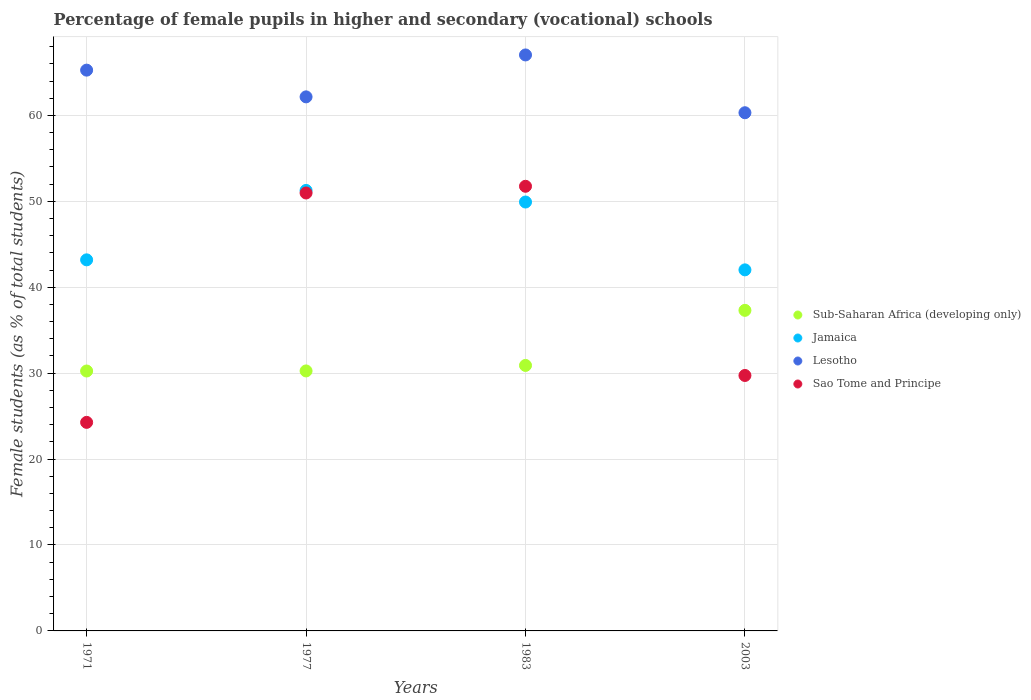How many different coloured dotlines are there?
Offer a very short reply. 4. Is the number of dotlines equal to the number of legend labels?
Your response must be concise. Yes. What is the percentage of female pupils in higher and secondary schools in Sub-Saharan Africa (developing only) in 1971?
Give a very brief answer. 30.25. Across all years, what is the maximum percentage of female pupils in higher and secondary schools in Sub-Saharan Africa (developing only)?
Provide a succinct answer. 37.31. Across all years, what is the minimum percentage of female pupils in higher and secondary schools in Sao Tome and Principe?
Offer a terse response. 24.27. In which year was the percentage of female pupils in higher and secondary schools in Lesotho maximum?
Give a very brief answer. 1983. In which year was the percentage of female pupils in higher and secondary schools in Lesotho minimum?
Keep it short and to the point. 2003. What is the total percentage of female pupils in higher and secondary schools in Lesotho in the graph?
Ensure brevity in your answer.  254.76. What is the difference between the percentage of female pupils in higher and secondary schools in Jamaica in 1971 and that in 2003?
Provide a short and direct response. 1.17. What is the difference between the percentage of female pupils in higher and secondary schools in Sao Tome and Principe in 1971 and the percentage of female pupils in higher and secondary schools in Jamaica in 2003?
Offer a terse response. -17.75. What is the average percentage of female pupils in higher and secondary schools in Lesotho per year?
Provide a succinct answer. 63.69. In the year 1971, what is the difference between the percentage of female pupils in higher and secondary schools in Jamaica and percentage of female pupils in higher and secondary schools in Sub-Saharan Africa (developing only)?
Give a very brief answer. 12.94. What is the ratio of the percentage of female pupils in higher and secondary schools in Jamaica in 1977 to that in 2003?
Offer a terse response. 1.22. Is the difference between the percentage of female pupils in higher and secondary schools in Jamaica in 1971 and 2003 greater than the difference between the percentage of female pupils in higher and secondary schools in Sub-Saharan Africa (developing only) in 1971 and 2003?
Offer a very short reply. Yes. What is the difference between the highest and the second highest percentage of female pupils in higher and secondary schools in Jamaica?
Offer a very short reply. 1.35. What is the difference between the highest and the lowest percentage of female pupils in higher and secondary schools in Sao Tome and Principe?
Make the answer very short. 27.48. Is it the case that in every year, the sum of the percentage of female pupils in higher and secondary schools in Sub-Saharan Africa (developing only) and percentage of female pupils in higher and secondary schools in Jamaica  is greater than the sum of percentage of female pupils in higher and secondary schools in Sao Tome and Principe and percentage of female pupils in higher and secondary schools in Lesotho?
Ensure brevity in your answer.  Yes. Is it the case that in every year, the sum of the percentage of female pupils in higher and secondary schools in Sub-Saharan Africa (developing only) and percentage of female pupils in higher and secondary schools in Sao Tome and Principe  is greater than the percentage of female pupils in higher and secondary schools in Lesotho?
Your answer should be compact. No. Is the percentage of female pupils in higher and secondary schools in Sub-Saharan Africa (developing only) strictly less than the percentage of female pupils in higher and secondary schools in Lesotho over the years?
Your answer should be compact. Yes. How many dotlines are there?
Your answer should be compact. 4. Does the graph contain any zero values?
Offer a very short reply. No. Does the graph contain grids?
Provide a succinct answer. Yes. Where does the legend appear in the graph?
Make the answer very short. Center right. How many legend labels are there?
Offer a terse response. 4. What is the title of the graph?
Provide a succinct answer. Percentage of female pupils in higher and secondary (vocational) schools. Does "Cameroon" appear as one of the legend labels in the graph?
Your answer should be compact. No. What is the label or title of the X-axis?
Give a very brief answer. Years. What is the label or title of the Y-axis?
Your answer should be very brief. Female students (as % of total students). What is the Female students (as % of total students) of Sub-Saharan Africa (developing only) in 1971?
Offer a terse response. 30.25. What is the Female students (as % of total students) in Jamaica in 1971?
Ensure brevity in your answer.  43.19. What is the Female students (as % of total students) in Lesotho in 1971?
Keep it short and to the point. 65.27. What is the Female students (as % of total students) in Sao Tome and Principe in 1971?
Your answer should be very brief. 24.27. What is the Female students (as % of total students) in Sub-Saharan Africa (developing only) in 1977?
Ensure brevity in your answer.  30.26. What is the Female students (as % of total students) in Jamaica in 1977?
Provide a short and direct response. 51.27. What is the Female students (as % of total students) in Lesotho in 1977?
Make the answer very short. 62.16. What is the Female students (as % of total students) in Sao Tome and Principe in 1977?
Ensure brevity in your answer.  50.97. What is the Female students (as % of total students) of Sub-Saharan Africa (developing only) in 1983?
Provide a succinct answer. 30.9. What is the Female students (as % of total students) of Jamaica in 1983?
Your answer should be very brief. 49.92. What is the Female students (as % of total students) in Lesotho in 1983?
Make the answer very short. 67.03. What is the Female students (as % of total students) of Sao Tome and Principe in 1983?
Offer a very short reply. 51.75. What is the Female students (as % of total students) of Sub-Saharan Africa (developing only) in 2003?
Keep it short and to the point. 37.31. What is the Female students (as % of total students) of Jamaica in 2003?
Provide a succinct answer. 42.02. What is the Female students (as % of total students) of Lesotho in 2003?
Offer a terse response. 60.31. What is the Female students (as % of total students) of Sao Tome and Principe in 2003?
Keep it short and to the point. 29.73. Across all years, what is the maximum Female students (as % of total students) of Sub-Saharan Africa (developing only)?
Make the answer very short. 37.31. Across all years, what is the maximum Female students (as % of total students) of Jamaica?
Ensure brevity in your answer.  51.27. Across all years, what is the maximum Female students (as % of total students) of Lesotho?
Offer a very short reply. 67.03. Across all years, what is the maximum Female students (as % of total students) of Sao Tome and Principe?
Offer a very short reply. 51.75. Across all years, what is the minimum Female students (as % of total students) of Sub-Saharan Africa (developing only)?
Provide a short and direct response. 30.25. Across all years, what is the minimum Female students (as % of total students) of Jamaica?
Provide a succinct answer. 42.02. Across all years, what is the minimum Female students (as % of total students) in Lesotho?
Your answer should be compact. 60.31. Across all years, what is the minimum Female students (as % of total students) of Sao Tome and Principe?
Provide a short and direct response. 24.27. What is the total Female students (as % of total students) in Sub-Saharan Africa (developing only) in the graph?
Your answer should be very brief. 128.72. What is the total Female students (as % of total students) in Jamaica in the graph?
Provide a short and direct response. 186.39. What is the total Female students (as % of total students) of Lesotho in the graph?
Give a very brief answer. 254.76. What is the total Female students (as % of total students) in Sao Tome and Principe in the graph?
Ensure brevity in your answer.  156.72. What is the difference between the Female students (as % of total students) in Sub-Saharan Africa (developing only) in 1971 and that in 1977?
Give a very brief answer. -0.01. What is the difference between the Female students (as % of total students) of Jamaica in 1971 and that in 1977?
Give a very brief answer. -8.08. What is the difference between the Female students (as % of total students) in Lesotho in 1971 and that in 1977?
Offer a terse response. 3.11. What is the difference between the Female students (as % of total students) of Sao Tome and Principe in 1971 and that in 1977?
Give a very brief answer. -26.7. What is the difference between the Female students (as % of total students) of Sub-Saharan Africa (developing only) in 1971 and that in 1983?
Offer a terse response. -0.65. What is the difference between the Female students (as % of total students) in Jamaica in 1971 and that in 1983?
Ensure brevity in your answer.  -6.73. What is the difference between the Female students (as % of total students) of Lesotho in 1971 and that in 1983?
Provide a succinct answer. -1.77. What is the difference between the Female students (as % of total students) of Sao Tome and Principe in 1971 and that in 1983?
Give a very brief answer. -27.48. What is the difference between the Female students (as % of total students) of Sub-Saharan Africa (developing only) in 1971 and that in 2003?
Keep it short and to the point. -7.06. What is the difference between the Female students (as % of total students) of Jamaica in 1971 and that in 2003?
Keep it short and to the point. 1.17. What is the difference between the Female students (as % of total students) of Lesotho in 1971 and that in 2003?
Offer a terse response. 4.96. What is the difference between the Female students (as % of total students) in Sao Tome and Principe in 1971 and that in 2003?
Provide a succinct answer. -5.46. What is the difference between the Female students (as % of total students) of Sub-Saharan Africa (developing only) in 1977 and that in 1983?
Offer a terse response. -0.64. What is the difference between the Female students (as % of total students) in Jamaica in 1977 and that in 1983?
Make the answer very short. 1.35. What is the difference between the Female students (as % of total students) of Lesotho in 1977 and that in 1983?
Your answer should be very brief. -4.88. What is the difference between the Female students (as % of total students) in Sao Tome and Principe in 1977 and that in 1983?
Your answer should be compact. -0.78. What is the difference between the Female students (as % of total students) in Sub-Saharan Africa (developing only) in 1977 and that in 2003?
Offer a very short reply. -7.05. What is the difference between the Female students (as % of total students) of Jamaica in 1977 and that in 2003?
Offer a very short reply. 9.24. What is the difference between the Female students (as % of total students) in Lesotho in 1977 and that in 2003?
Provide a short and direct response. 1.85. What is the difference between the Female students (as % of total students) of Sao Tome and Principe in 1977 and that in 2003?
Offer a very short reply. 21.24. What is the difference between the Female students (as % of total students) in Sub-Saharan Africa (developing only) in 1983 and that in 2003?
Your response must be concise. -6.41. What is the difference between the Female students (as % of total students) of Jamaica in 1983 and that in 2003?
Provide a short and direct response. 7.9. What is the difference between the Female students (as % of total students) of Lesotho in 1983 and that in 2003?
Your response must be concise. 6.73. What is the difference between the Female students (as % of total students) of Sao Tome and Principe in 1983 and that in 2003?
Offer a very short reply. 22.02. What is the difference between the Female students (as % of total students) in Sub-Saharan Africa (developing only) in 1971 and the Female students (as % of total students) in Jamaica in 1977?
Your response must be concise. -21.02. What is the difference between the Female students (as % of total students) in Sub-Saharan Africa (developing only) in 1971 and the Female students (as % of total students) in Lesotho in 1977?
Offer a very short reply. -31.91. What is the difference between the Female students (as % of total students) of Sub-Saharan Africa (developing only) in 1971 and the Female students (as % of total students) of Sao Tome and Principe in 1977?
Keep it short and to the point. -20.72. What is the difference between the Female students (as % of total students) of Jamaica in 1971 and the Female students (as % of total students) of Lesotho in 1977?
Your answer should be compact. -18.97. What is the difference between the Female students (as % of total students) in Jamaica in 1971 and the Female students (as % of total students) in Sao Tome and Principe in 1977?
Provide a short and direct response. -7.78. What is the difference between the Female students (as % of total students) of Lesotho in 1971 and the Female students (as % of total students) of Sao Tome and Principe in 1977?
Offer a very short reply. 14.3. What is the difference between the Female students (as % of total students) in Sub-Saharan Africa (developing only) in 1971 and the Female students (as % of total students) in Jamaica in 1983?
Offer a very short reply. -19.67. What is the difference between the Female students (as % of total students) in Sub-Saharan Africa (developing only) in 1971 and the Female students (as % of total students) in Lesotho in 1983?
Give a very brief answer. -36.78. What is the difference between the Female students (as % of total students) of Sub-Saharan Africa (developing only) in 1971 and the Female students (as % of total students) of Sao Tome and Principe in 1983?
Your answer should be very brief. -21.5. What is the difference between the Female students (as % of total students) of Jamaica in 1971 and the Female students (as % of total students) of Lesotho in 1983?
Give a very brief answer. -23.85. What is the difference between the Female students (as % of total students) of Jamaica in 1971 and the Female students (as % of total students) of Sao Tome and Principe in 1983?
Provide a succinct answer. -8.56. What is the difference between the Female students (as % of total students) in Lesotho in 1971 and the Female students (as % of total students) in Sao Tome and Principe in 1983?
Provide a short and direct response. 13.52. What is the difference between the Female students (as % of total students) in Sub-Saharan Africa (developing only) in 1971 and the Female students (as % of total students) in Jamaica in 2003?
Ensure brevity in your answer.  -11.77. What is the difference between the Female students (as % of total students) of Sub-Saharan Africa (developing only) in 1971 and the Female students (as % of total students) of Lesotho in 2003?
Offer a terse response. -30.06. What is the difference between the Female students (as % of total students) of Sub-Saharan Africa (developing only) in 1971 and the Female students (as % of total students) of Sao Tome and Principe in 2003?
Provide a succinct answer. 0.52. What is the difference between the Female students (as % of total students) in Jamaica in 1971 and the Female students (as % of total students) in Lesotho in 2003?
Give a very brief answer. -17.12. What is the difference between the Female students (as % of total students) of Jamaica in 1971 and the Female students (as % of total students) of Sao Tome and Principe in 2003?
Your response must be concise. 13.46. What is the difference between the Female students (as % of total students) of Lesotho in 1971 and the Female students (as % of total students) of Sao Tome and Principe in 2003?
Ensure brevity in your answer.  35.54. What is the difference between the Female students (as % of total students) in Sub-Saharan Africa (developing only) in 1977 and the Female students (as % of total students) in Jamaica in 1983?
Provide a succinct answer. -19.66. What is the difference between the Female students (as % of total students) of Sub-Saharan Africa (developing only) in 1977 and the Female students (as % of total students) of Lesotho in 1983?
Provide a short and direct response. -36.77. What is the difference between the Female students (as % of total students) in Sub-Saharan Africa (developing only) in 1977 and the Female students (as % of total students) in Sao Tome and Principe in 1983?
Give a very brief answer. -21.49. What is the difference between the Female students (as % of total students) of Jamaica in 1977 and the Female students (as % of total students) of Lesotho in 1983?
Provide a short and direct response. -15.77. What is the difference between the Female students (as % of total students) in Jamaica in 1977 and the Female students (as % of total students) in Sao Tome and Principe in 1983?
Your answer should be compact. -0.48. What is the difference between the Female students (as % of total students) in Lesotho in 1977 and the Female students (as % of total students) in Sao Tome and Principe in 1983?
Your response must be concise. 10.41. What is the difference between the Female students (as % of total students) in Sub-Saharan Africa (developing only) in 1977 and the Female students (as % of total students) in Jamaica in 2003?
Give a very brief answer. -11.76. What is the difference between the Female students (as % of total students) in Sub-Saharan Africa (developing only) in 1977 and the Female students (as % of total students) in Lesotho in 2003?
Give a very brief answer. -30.05. What is the difference between the Female students (as % of total students) of Sub-Saharan Africa (developing only) in 1977 and the Female students (as % of total students) of Sao Tome and Principe in 2003?
Give a very brief answer. 0.53. What is the difference between the Female students (as % of total students) of Jamaica in 1977 and the Female students (as % of total students) of Lesotho in 2003?
Make the answer very short. -9.04. What is the difference between the Female students (as % of total students) of Jamaica in 1977 and the Female students (as % of total students) of Sao Tome and Principe in 2003?
Give a very brief answer. 21.54. What is the difference between the Female students (as % of total students) in Lesotho in 1977 and the Female students (as % of total students) in Sao Tome and Principe in 2003?
Your answer should be compact. 32.43. What is the difference between the Female students (as % of total students) of Sub-Saharan Africa (developing only) in 1983 and the Female students (as % of total students) of Jamaica in 2003?
Offer a very short reply. -11.12. What is the difference between the Female students (as % of total students) of Sub-Saharan Africa (developing only) in 1983 and the Female students (as % of total students) of Lesotho in 2003?
Your answer should be very brief. -29.41. What is the difference between the Female students (as % of total students) of Sub-Saharan Africa (developing only) in 1983 and the Female students (as % of total students) of Sao Tome and Principe in 2003?
Provide a short and direct response. 1.17. What is the difference between the Female students (as % of total students) in Jamaica in 1983 and the Female students (as % of total students) in Lesotho in 2003?
Ensure brevity in your answer.  -10.39. What is the difference between the Female students (as % of total students) of Jamaica in 1983 and the Female students (as % of total students) of Sao Tome and Principe in 2003?
Keep it short and to the point. 20.19. What is the difference between the Female students (as % of total students) of Lesotho in 1983 and the Female students (as % of total students) of Sao Tome and Principe in 2003?
Offer a terse response. 37.3. What is the average Female students (as % of total students) of Sub-Saharan Africa (developing only) per year?
Your response must be concise. 32.18. What is the average Female students (as % of total students) in Jamaica per year?
Provide a short and direct response. 46.6. What is the average Female students (as % of total students) of Lesotho per year?
Make the answer very short. 63.69. What is the average Female students (as % of total students) in Sao Tome and Principe per year?
Ensure brevity in your answer.  39.18. In the year 1971, what is the difference between the Female students (as % of total students) of Sub-Saharan Africa (developing only) and Female students (as % of total students) of Jamaica?
Provide a short and direct response. -12.94. In the year 1971, what is the difference between the Female students (as % of total students) of Sub-Saharan Africa (developing only) and Female students (as % of total students) of Lesotho?
Offer a terse response. -35.02. In the year 1971, what is the difference between the Female students (as % of total students) of Sub-Saharan Africa (developing only) and Female students (as % of total students) of Sao Tome and Principe?
Provide a succinct answer. 5.98. In the year 1971, what is the difference between the Female students (as % of total students) in Jamaica and Female students (as % of total students) in Lesotho?
Ensure brevity in your answer.  -22.08. In the year 1971, what is the difference between the Female students (as % of total students) in Jamaica and Female students (as % of total students) in Sao Tome and Principe?
Give a very brief answer. 18.92. In the year 1971, what is the difference between the Female students (as % of total students) in Lesotho and Female students (as % of total students) in Sao Tome and Principe?
Offer a terse response. 40.99. In the year 1977, what is the difference between the Female students (as % of total students) of Sub-Saharan Africa (developing only) and Female students (as % of total students) of Jamaica?
Ensure brevity in your answer.  -21.01. In the year 1977, what is the difference between the Female students (as % of total students) in Sub-Saharan Africa (developing only) and Female students (as % of total students) in Lesotho?
Provide a short and direct response. -31.9. In the year 1977, what is the difference between the Female students (as % of total students) in Sub-Saharan Africa (developing only) and Female students (as % of total students) in Sao Tome and Principe?
Offer a very short reply. -20.71. In the year 1977, what is the difference between the Female students (as % of total students) in Jamaica and Female students (as % of total students) in Lesotho?
Give a very brief answer. -10.89. In the year 1977, what is the difference between the Female students (as % of total students) of Jamaica and Female students (as % of total students) of Sao Tome and Principe?
Keep it short and to the point. 0.3. In the year 1977, what is the difference between the Female students (as % of total students) of Lesotho and Female students (as % of total students) of Sao Tome and Principe?
Your response must be concise. 11.19. In the year 1983, what is the difference between the Female students (as % of total students) in Sub-Saharan Africa (developing only) and Female students (as % of total students) in Jamaica?
Offer a very short reply. -19.02. In the year 1983, what is the difference between the Female students (as % of total students) in Sub-Saharan Africa (developing only) and Female students (as % of total students) in Lesotho?
Ensure brevity in your answer.  -36.14. In the year 1983, what is the difference between the Female students (as % of total students) in Sub-Saharan Africa (developing only) and Female students (as % of total students) in Sao Tome and Principe?
Offer a terse response. -20.85. In the year 1983, what is the difference between the Female students (as % of total students) of Jamaica and Female students (as % of total students) of Lesotho?
Your response must be concise. -17.12. In the year 1983, what is the difference between the Female students (as % of total students) in Jamaica and Female students (as % of total students) in Sao Tome and Principe?
Keep it short and to the point. -1.83. In the year 1983, what is the difference between the Female students (as % of total students) of Lesotho and Female students (as % of total students) of Sao Tome and Principe?
Provide a short and direct response. 15.29. In the year 2003, what is the difference between the Female students (as % of total students) in Sub-Saharan Africa (developing only) and Female students (as % of total students) in Jamaica?
Your answer should be compact. -4.71. In the year 2003, what is the difference between the Female students (as % of total students) of Sub-Saharan Africa (developing only) and Female students (as % of total students) of Lesotho?
Ensure brevity in your answer.  -23. In the year 2003, what is the difference between the Female students (as % of total students) of Sub-Saharan Africa (developing only) and Female students (as % of total students) of Sao Tome and Principe?
Offer a terse response. 7.58. In the year 2003, what is the difference between the Female students (as % of total students) in Jamaica and Female students (as % of total students) in Lesotho?
Offer a terse response. -18.29. In the year 2003, what is the difference between the Female students (as % of total students) in Jamaica and Female students (as % of total students) in Sao Tome and Principe?
Offer a very short reply. 12.29. In the year 2003, what is the difference between the Female students (as % of total students) in Lesotho and Female students (as % of total students) in Sao Tome and Principe?
Provide a short and direct response. 30.58. What is the ratio of the Female students (as % of total students) of Sub-Saharan Africa (developing only) in 1971 to that in 1977?
Your answer should be compact. 1. What is the ratio of the Female students (as % of total students) of Jamaica in 1971 to that in 1977?
Offer a very short reply. 0.84. What is the ratio of the Female students (as % of total students) in Sao Tome and Principe in 1971 to that in 1977?
Give a very brief answer. 0.48. What is the ratio of the Female students (as % of total students) in Jamaica in 1971 to that in 1983?
Make the answer very short. 0.87. What is the ratio of the Female students (as % of total students) in Lesotho in 1971 to that in 1983?
Provide a short and direct response. 0.97. What is the ratio of the Female students (as % of total students) in Sao Tome and Principe in 1971 to that in 1983?
Give a very brief answer. 0.47. What is the ratio of the Female students (as % of total students) in Sub-Saharan Africa (developing only) in 1971 to that in 2003?
Your answer should be compact. 0.81. What is the ratio of the Female students (as % of total students) in Jamaica in 1971 to that in 2003?
Offer a terse response. 1.03. What is the ratio of the Female students (as % of total students) in Lesotho in 1971 to that in 2003?
Your answer should be very brief. 1.08. What is the ratio of the Female students (as % of total students) of Sao Tome and Principe in 1971 to that in 2003?
Provide a short and direct response. 0.82. What is the ratio of the Female students (as % of total students) in Sub-Saharan Africa (developing only) in 1977 to that in 1983?
Provide a succinct answer. 0.98. What is the ratio of the Female students (as % of total students) in Jamaica in 1977 to that in 1983?
Your answer should be very brief. 1.03. What is the ratio of the Female students (as % of total students) of Lesotho in 1977 to that in 1983?
Offer a very short reply. 0.93. What is the ratio of the Female students (as % of total students) of Sao Tome and Principe in 1977 to that in 1983?
Offer a very short reply. 0.98. What is the ratio of the Female students (as % of total students) of Sub-Saharan Africa (developing only) in 1977 to that in 2003?
Provide a succinct answer. 0.81. What is the ratio of the Female students (as % of total students) in Jamaica in 1977 to that in 2003?
Ensure brevity in your answer.  1.22. What is the ratio of the Female students (as % of total students) of Lesotho in 1977 to that in 2003?
Give a very brief answer. 1.03. What is the ratio of the Female students (as % of total students) of Sao Tome and Principe in 1977 to that in 2003?
Your answer should be very brief. 1.71. What is the ratio of the Female students (as % of total students) of Sub-Saharan Africa (developing only) in 1983 to that in 2003?
Provide a short and direct response. 0.83. What is the ratio of the Female students (as % of total students) in Jamaica in 1983 to that in 2003?
Offer a terse response. 1.19. What is the ratio of the Female students (as % of total students) of Lesotho in 1983 to that in 2003?
Provide a succinct answer. 1.11. What is the ratio of the Female students (as % of total students) of Sao Tome and Principe in 1983 to that in 2003?
Provide a succinct answer. 1.74. What is the difference between the highest and the second highest Female students (as % of total students) of Sub-Saharan Africa (developing only)?
Give a very brief answer. 6.41. What is the difference between the highest and the second highest Female students (as % of total students) of Jamaica?
Your answer should be very brief. 1.35. What is the difference between the highest and the second highest Female students (as % of total students) in Lesotho?
Give a very brief answer. 1.77. What is the difference between the highest and the second highest Female students (as % of total students) in Sao Tome and Principe?
Offer a very short reply. 0.78. What is the difference between the highest and the lowest Female students (as % of total students) of Sub-Saharan Africa (developing only)?
Your response must be concise. 7.06. What is the difference between the highest and the lowest Female students (as % of total students) in Jamaica?
Offer a very short reply. 9.24. What is the difference between the highest and the lowest Female students (as % of total students) of Lesotho?
Keep it short and to the point. 6.73. What is the difference between the highest and the lowest Female students (as % of total students) of Sao Tome and Principe?
Provide a succinct answer. 27.48. 